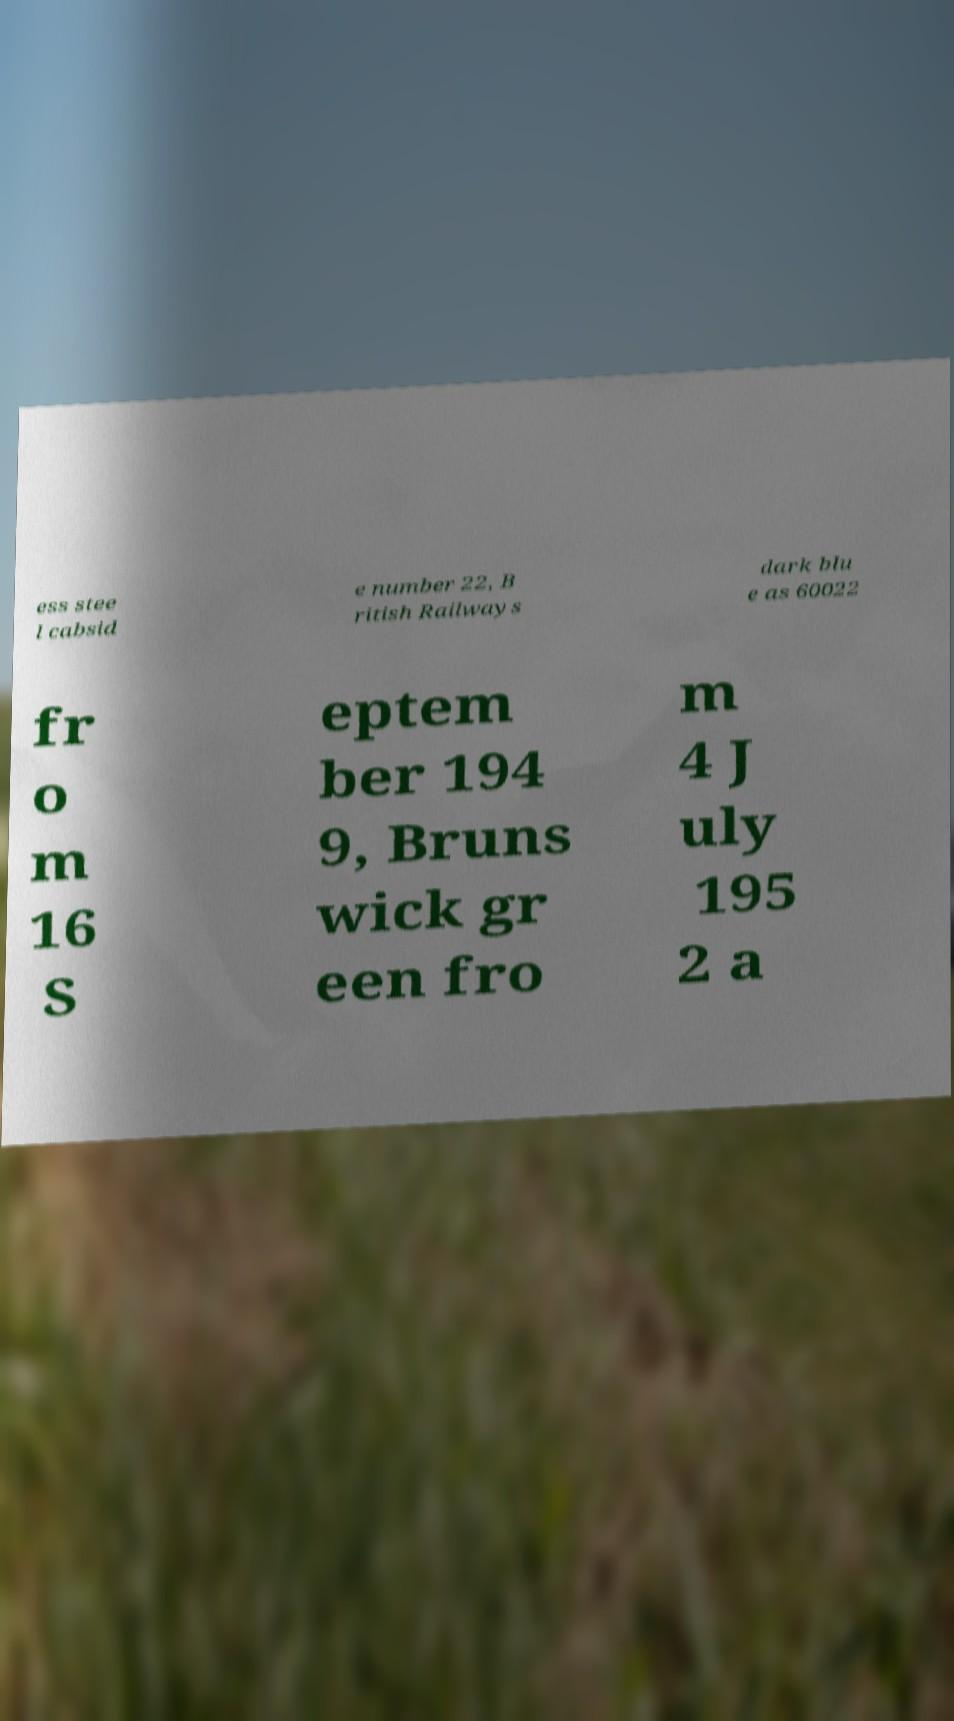Please read and relay the text visible in this image. What does it say? ess stee l cabsid e number 22, B ritish Railways dark blu e as 60022 fr o m 16 S eptem ber 194 9, Bruns wick gr een fro m 4 J uly 195 2 a 